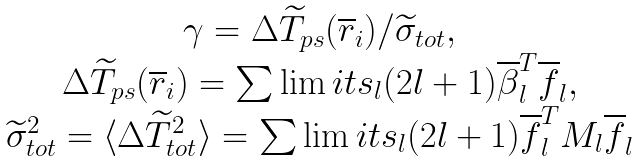Convert formula to latex. <formula><loc_0><loc_0><loc_500><loc_500>\begin{array} { c } \gamma = \Delta \widetilde { T } _ { p s } ( \overline { r } _ { i } ) / \widetilde { \sigma } _ { t o t } , \\ \Delta \widetilde { T } _ { p s } ( \overline { r } _ { i } ) = \sum \lim i t s _ { l } ( 2 l + 1 ) \overline { \beta } _ { l } ^ { T } \overline { f } _ { l } , \\ \widetilde { \sigma } _ { t o t } ^ { 2 } = \langle \Delta \widetilde { T } _ { t o t } ^ { 2 } \rangle = \sum \lim i t s _ { l } ( 2 l + 1 ) \overline { f } _ { l } ^ { T } M _ { l } \overline { f } _ { l } \end{array}</formula> 